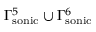Convert formula to latex. <formula><loc_0><loc_0><loc_500><loc_500>\Gamma _ { s o n i c } ^ { 5 } \cup \Gamma _ { s o n i c } ^ { 6 }</formula> 